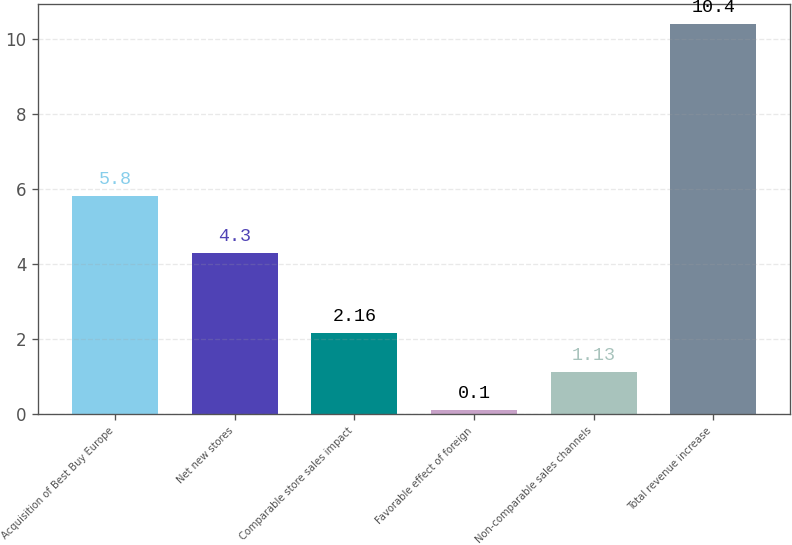Convert chart. <chart><loc_0><loc_0><loc_500><loc_500><bar_chart><fcel>Acquisition of Best Buy Europe<fcel>Net new stores<fcel>Comparable store sales impact<fcel>Favorable effect of foreign<fcel>Non-comparable sales channels<fcel>Total revenue increase<nl><fcel>5.8<fcel>4.3<fcel>2.16<fcel>0.1<fcel>1.13<fcel>10.4<nl></chart> 